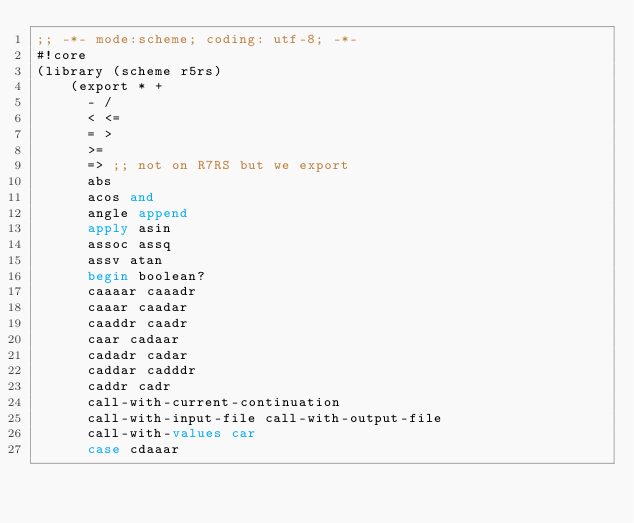<code> <loc_0><loc_0><loc_500><loc_500><_Scheme_>;; -*- mode:scheme; coding: utf-8; -*-
#!core
(library (scheme r5rs)
    (export * +
	    - /
	    < <=
	    = >
	    >= 
	    => ;; not on R7RS but we export
	    abs
	    acos and
	    angle append
	    apply asin
	    assoc assq
	    assv atan
	    begin boolean?
	    caaaar caaadr
	    caaar caadar
	    caaddr caadr
	    caar cadaar
	    cadadr cadar
	    caddar cadddr
	    caddr cadr
	    call-with-current-continuation
	    call-with-input-file call-with-output-file
	    call-with-values car
	    case cdaaar</code> 